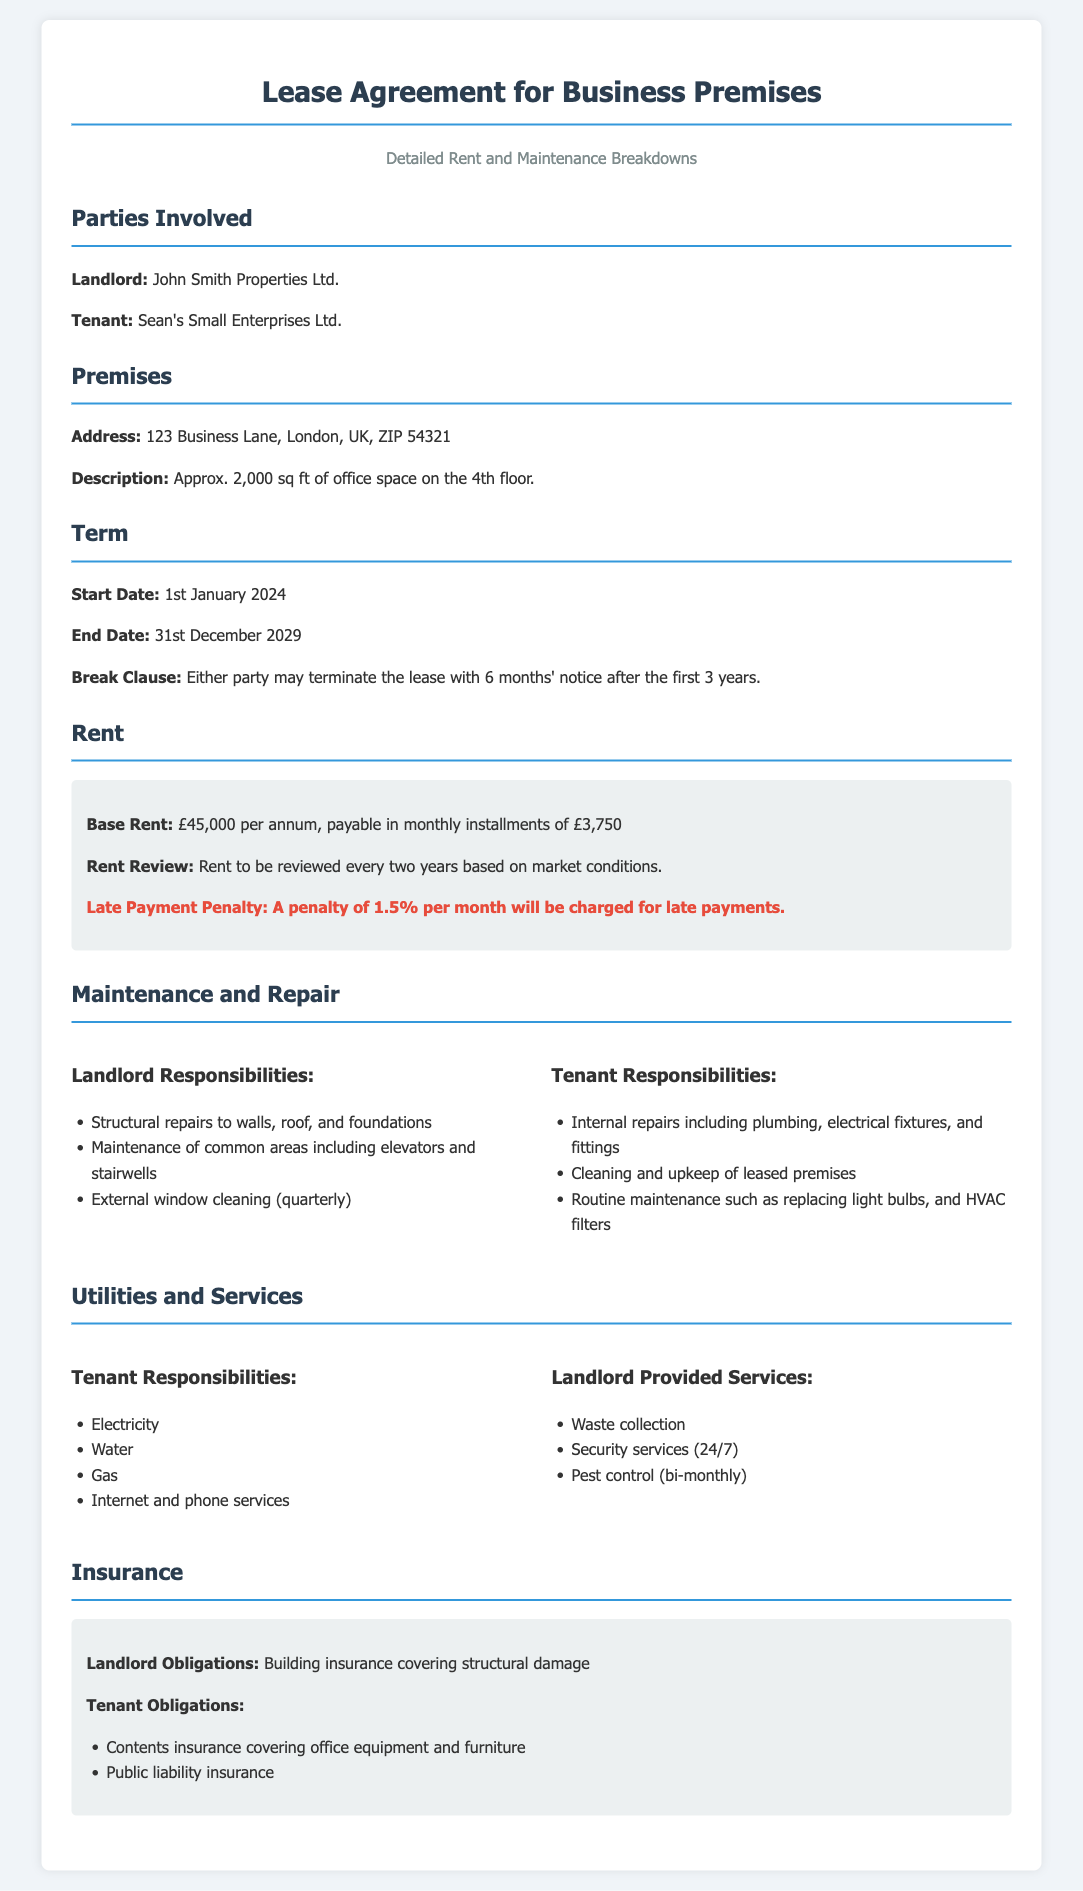what is the name of the landlord? The landlord is specified in the document as John Smith Properties Ltd.
Answer: John Smith Properties Ltd what is the address of the premises? The premises address is provided in the document as 123 Business Lane, London, UK, ZIP 54321.
Answer: 123 Business Lane, London, UK, ZIP 54321 when does the lease start? The start date of the lease is outlined in the document as 1st January 2024.
Answer: 1st January 2024 what is the base rent per annum? The document states that the base rent is £45,000 per annum.
Answer: £45,000 how much is the late payment penalty? The late payment penalty is detailed in the document as 1.5% per month for late payments.
Answer: 1.5% who is responsible for external window cleaning? The document indicates that external window cleaning is a responsibility of the landlord.
Answer: Landlord what type of insurance does the tenant need? The document lists that the tenant needs contents insurance covering office equipment and furniture.
Answer: Contents insurance what is the duration of the lease term? The document specifies that the lease term is from 1st January 2024 to 31st December 2029, amounting to 5 years.
Answer: 5 years what is required from either party to terminate the lease after the first 3 years? The document states that either party may terminate the lease with 6 months' notice after the first 3 years.
Answer: 6 months' notice what type of maintenance is the tenant responsible for? The tenant is responsible for internal repairs, including plumbing and electrical fixtures as per the document.
Answer: Internal repairs 